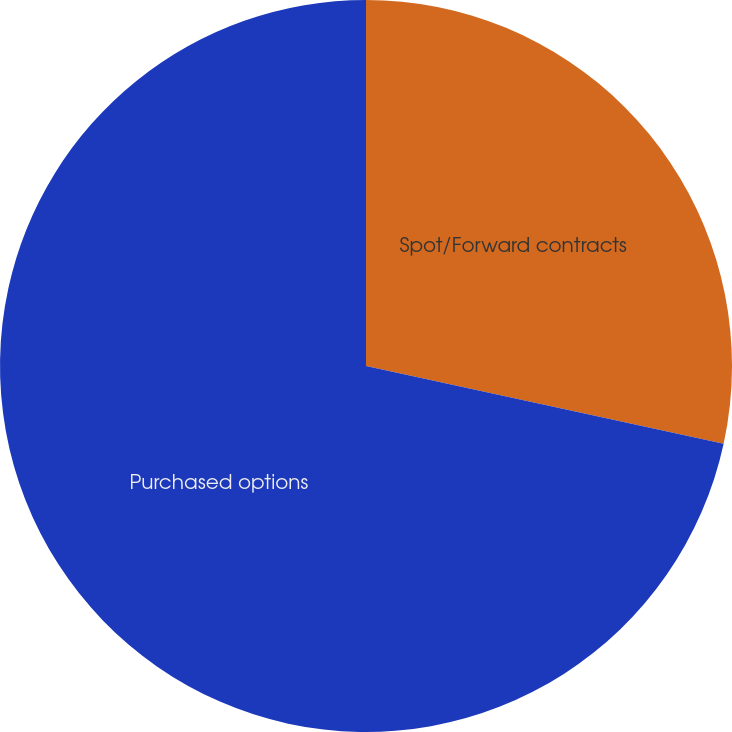<chart> <loc_0><loc_0><loc_500><loc_500><pie_chart><fcel>Spot/Forward contracts<fcel>Purchased options<nl><fcel>28.41%<fcel>71.59%<nl></chart> 